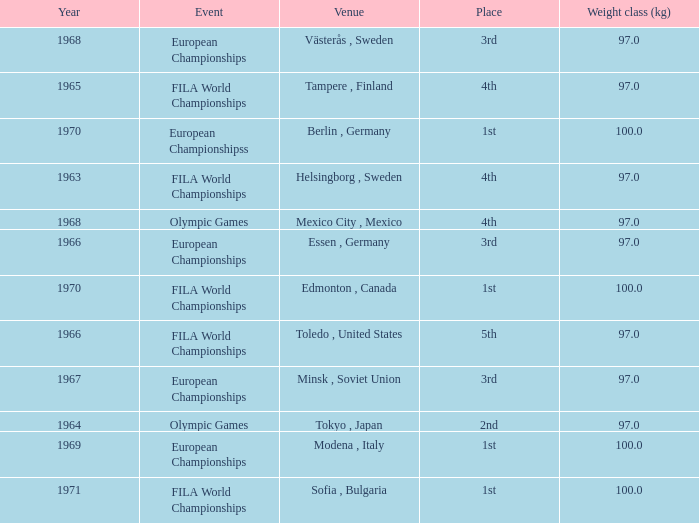What is the lowest weight class (kg) that has sofia, bulgaria as the venue? 100.0. 